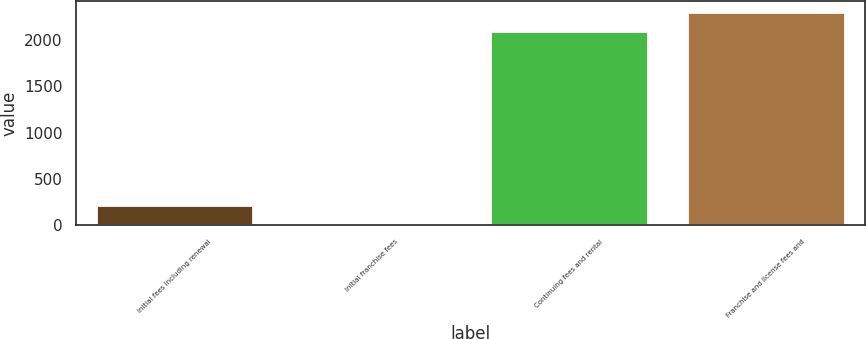Convert chart to OTSL. <chart><loc_0><loc_0><loc_500><loc_500><bar_chart><fcel>Initial fees including renewal<fcel>Initial franchise fees<fcel>Continuing fees and rental<fcel>Franchise and license fees and<nl><fcel>224.7<fcel>9<fcel>2094<fcel>2309.7<nl></chart> 